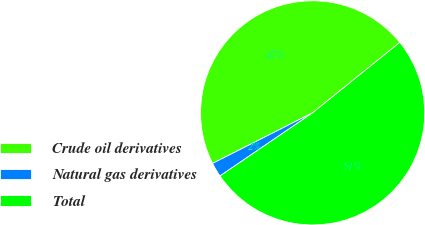<chart> <loc_0><loc_0><loc_500><loc_500><pie_chart><fcel>Crude oil derivatives<fcel>Natural gas derivatives<fcel>Total<nl><fcel>46.63%<fcel>2.07%<fcel>51.3%<nl></chart> 